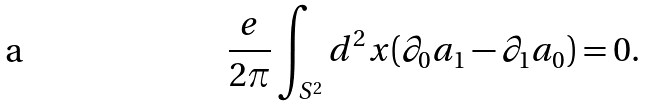Convert formula to latex. <formula><loc_0><loc_0><loc_500><loc_500>\frac { e } { 2 \pi } \int _ { S ^ { 2 } } d ^ { 2 } x ( \partial _ { 0 } a _ { 1 } - \partial _ { 1 } a _ { 0 } ) = 0 .</formula> 